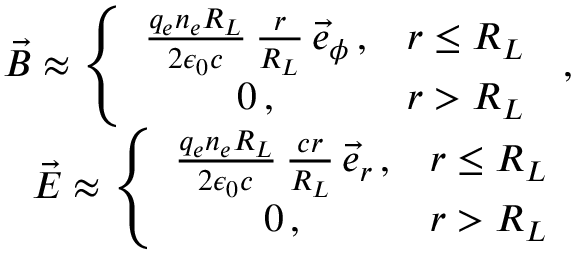<formula> <loc_0><loc_0><loc_500><loc_500>\begin{array} { r l r } & { \vec { B } \approx \left \{ \begin{array} { c c } { \frac { q _ { e } n _ { e } R _ { L } } { 2 \epsilon _ { 0 } c } \, \frac { r } { R _ { L } } \, \vec { e } _ { \phi } \, , } & { r \leq R _ { L } } \\ { 0 \, , } & { r > R _ { L } } \end{array} \, , } \\ & { \vec { E } \approx \left \{ \begin{array} { c c } { \frac { q _ { e } n _ { e } R _ { L } } { 2 \epsilon _ { 0 } c } \, \frac { c r } { R _ { L } } \, \vec { e } _ { r } \, , } & { r \leq R _ { L } } \\ { 0 \, , } & { r > R _ { L } } \end{array} } \end{array}</formula> 